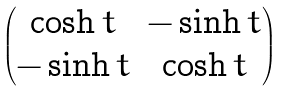Convert formula to latex. <formula><loc_0><loc_0><loc_500><loc_500>\begin{pmatrix} \cosh t & - \sinh t \\ - \sinh t & \cosh t \end{pmatrix}</formula> 